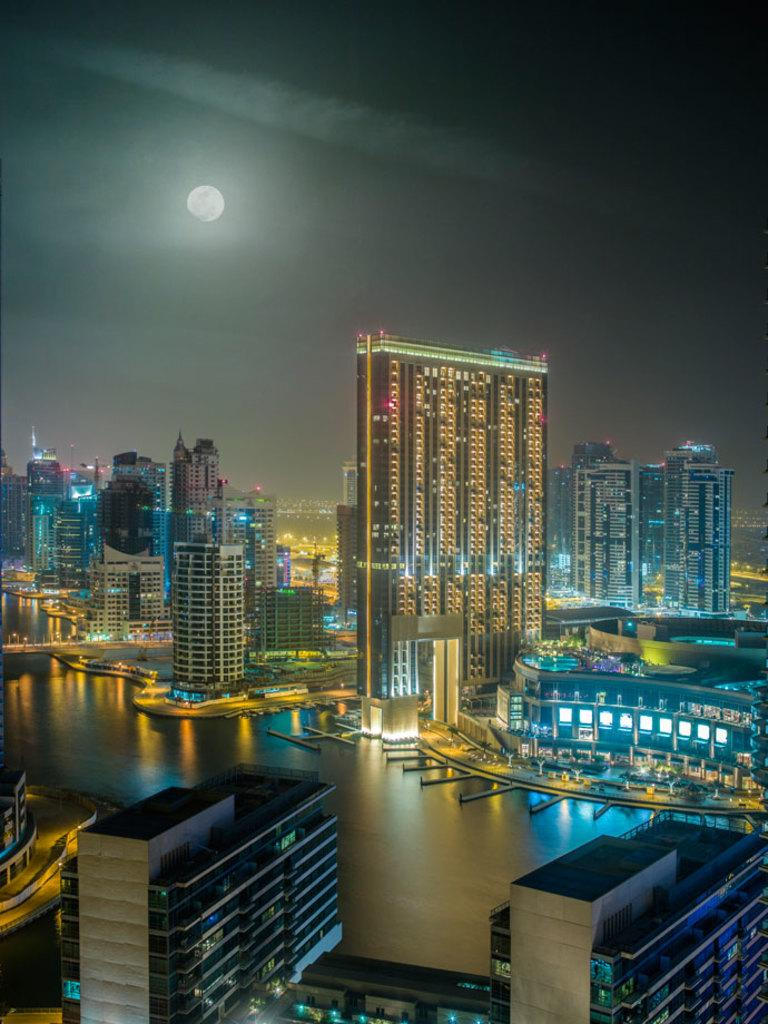What type of structures can be seen in the image? There are multiple buildings in the image. What natural feature is present in the image? There is a river flowing in the image. What can be seen in the background of the image? The sky is visible in the background of the image. What celestial body is observable in the sky? The moon is observable in the sky. What type of dress is the visitor wearing in the image? There is no visitor present in the image, so it is not possible to determine what type of dress they might be wearing. 